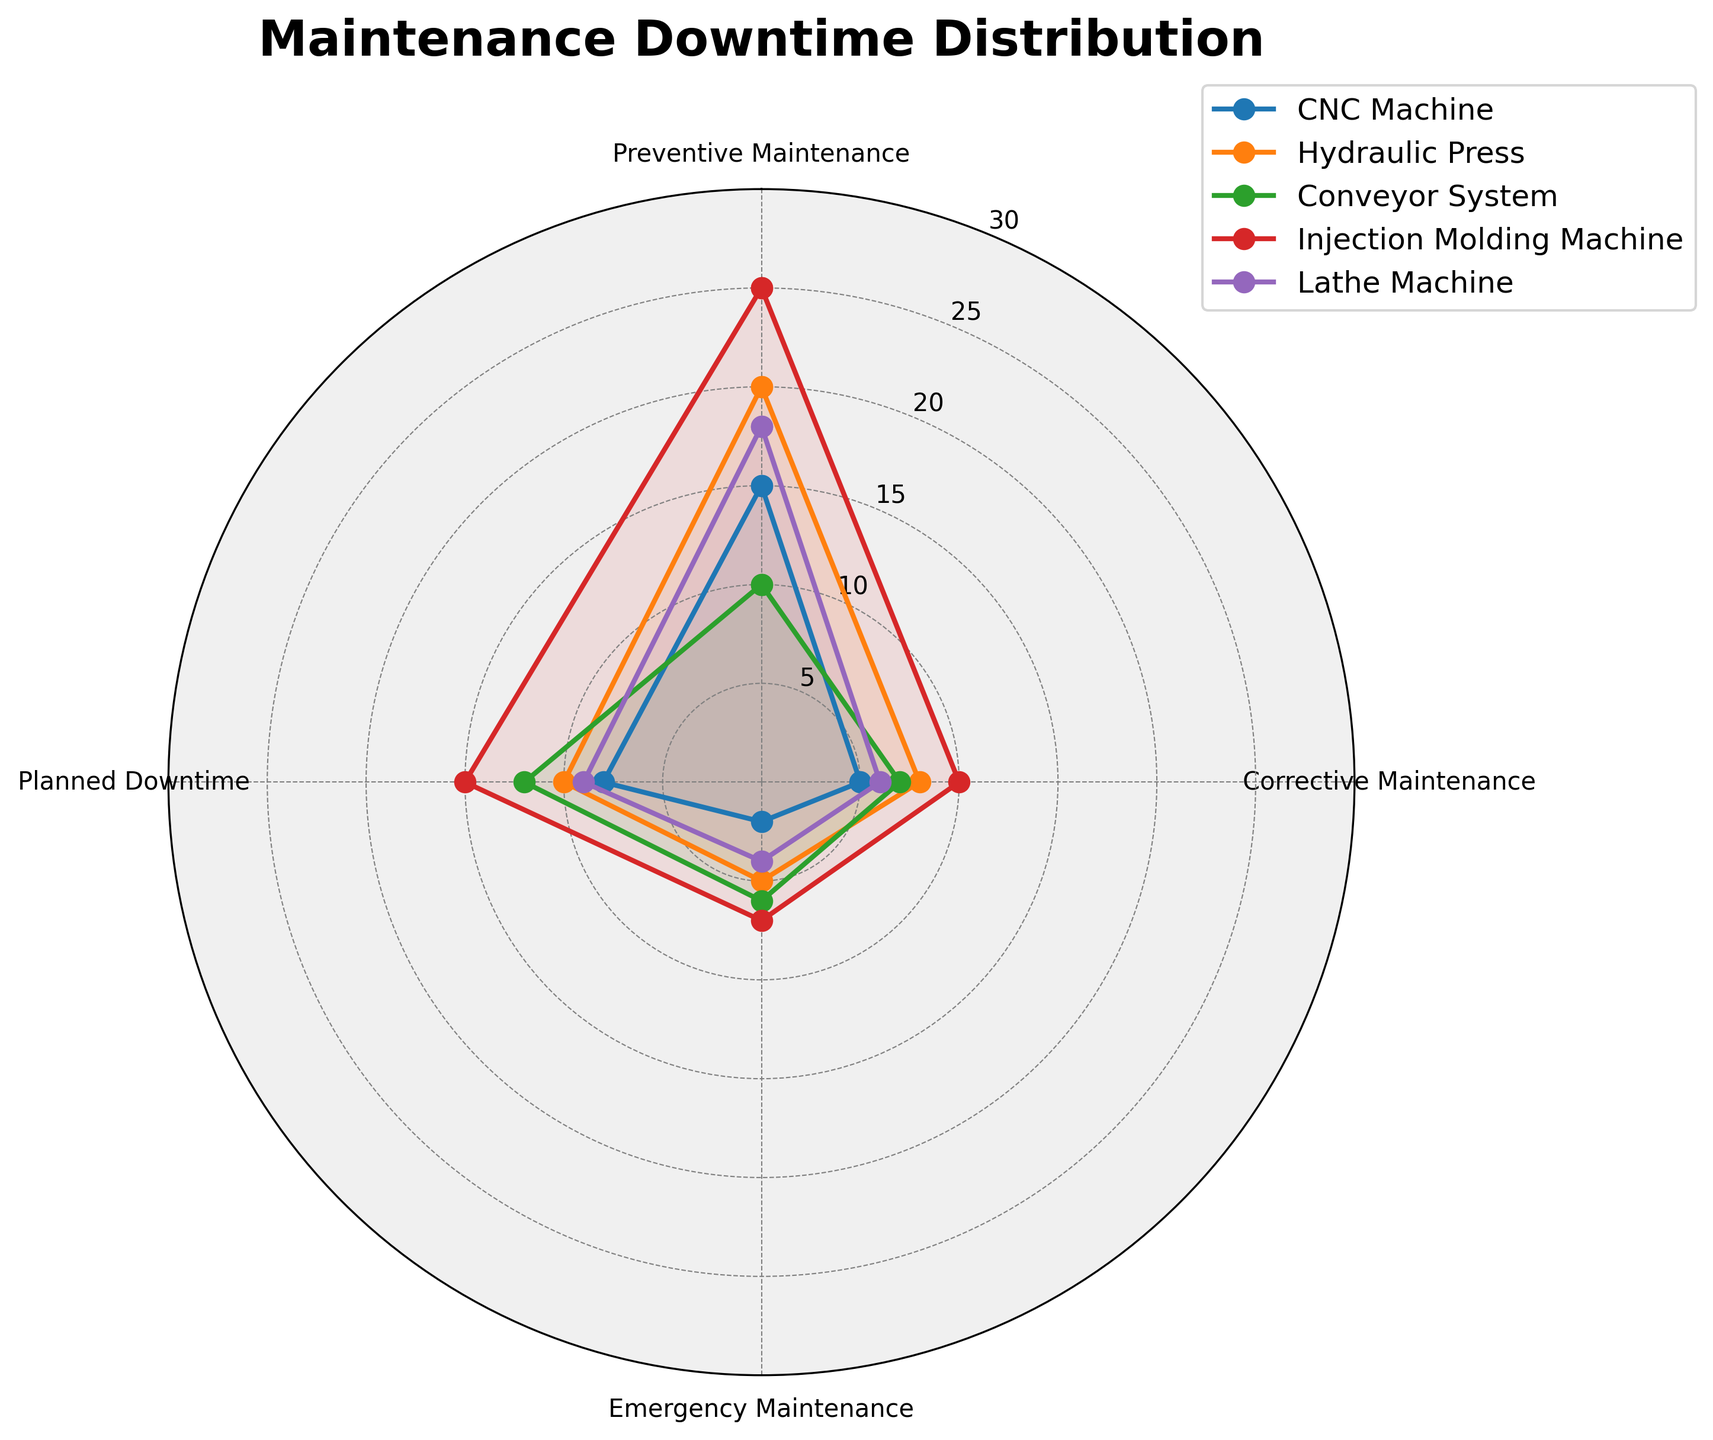What is the title of the chart? The title is generally displayed at the top of the chart. It helps provide immediate context about the subject matter of the chart. Here, the title "Maintenance Downtime Distribution" is easily noticeable at the top.
Answer: Maintenance Downtime Distribution How many types of machinery are compared in the chart? You can count the number of distinct lines or legends in the chart to determine the number of machinery types. The chart includes five machinery types: CNC Machine, Hydraulic Press, Conveyor System, Injection Molding Machine, and Lathe Machine.
Answer: Five Which type of maintenance has the highest downtime for the Hydraulic Press? By referring to the section of the chart labeled "Hydraulic Press" and examining the four categories, "Preventive Maintenance" stands out as the highest value.
Answer: Preventive Maintenance What is the downtime for Emergency Maintenance in the Conveyor System? Find the section of the chart labeled "Conveyor System" and look at the marker closest to "Emergency Maintenance" to find its value, which is 6.
Answer: 6 How does the downtime for Planned Downtime compare between CNC Machine and Injection Molding Machine? Locate the values for "Planned Downtime" for both types. CNC Machine and Injection Molding Machine have values of 8 and 15 respectively, indicating the Injection Molding Machine has a greater planned downtime.
Answer: Injection Molding Machine has greater planned downtime What's the average downtime for Preventive Maintenance across all machinery? Calculate the values for Preventive Maintenance for each machine: 15 (CNC Machine), 20 (Hydraulic Press), 10 (Conveyor System), 25 (Injection Molding Machine), and 18 (Lathe Machine). Sum these values: 15 + 20 + 10 + 25 + 18 = 88. Divide by 5 to get the average: 88 / 5 = 17.6
Answer: 17.6 Which machinery has the lowest Corrective Maintenance downtime? Check each type's Corrective Maintenance values and find the lowest. The CNC Machine has the lowest value at 5.
Answer: CNC Machine Is the Preventive Maintenance downtime for the Injection Molding Machine greater than the combined Corrective Maintenance and Emergency Maintenance downtime for the Lathe Machine? First, note that the Preventive Maintenance downtime for the Injection Molding Machine is 25. For the Lathe Machine, sum the Corrective and Emergency Maintenance: 6 + 4 = 10. Compare 25 with 10, and yes, 25 is greater.
Answer: Yes What are the combined downtimes for Preventive and Corrective Maintenance for the CNC Machine? Find the values for Preventive and Corrective Maintenance for the CNC Machine: 15 and 5, respectively. Add these together: 15 + 5 = 20.
Answer: 20 Which type of maintenance shows the least variation across all machinery types? By visual inspection, compare the consistency of values for each maintenance type across different machines. "Emergency Maintenance" appears to have the least variation, with values clustered closely together.
Answer: Emergency Maintenance 